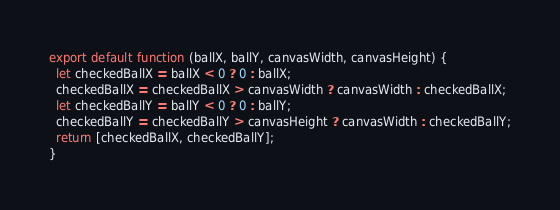Convert code to text. <code><loc_0><loc_0><loc_500><loc_500><_JavaScript_>export default function (ballX, ballY, canvasWidth, canvasHeight) {
  let checkedBallX = ballX < 0 ? 0 : ballX;
  checkedBallX = checkedBallX > canvasWidth ? canvasWidth : checkedBallX;
  let checkedBallY = ballY < 0 ? 0 : ballY;
  checkedBallY = checkedBallY > canvasHeight ? canvasWidth : checkedBallY;
  return [checkedBallX, checkedBallY];
}
</code> 